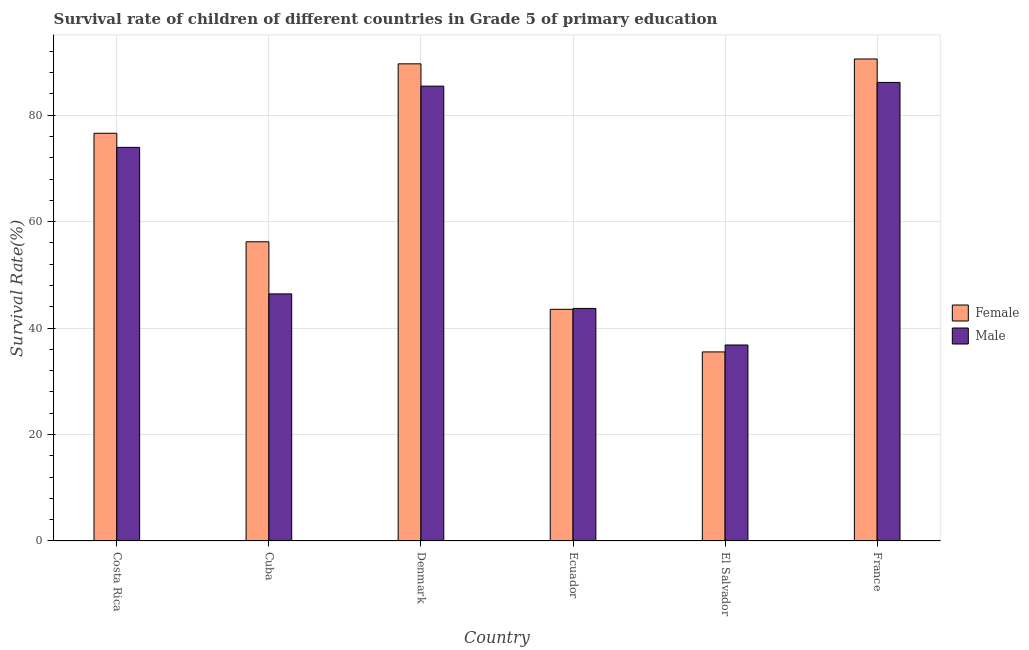How many groups of bars are there?
Your answer should be compact. 6. What is the label of the 6th group of bars from the left?
Provide a short and direct response. France. In how many cases, is the number of bars for a given country not equal to the number of legend labels?
Give a very brief answer. 0. What is the survival rate of female students in primary education in Ecuador?
Your answer should be very brief. 43.53. Across all countries, what is the maximum survival rate of female students in primary education?
Make the answer very short. 90.56. Across all countries, what is the minimum survival rate of female students in primary education?
Offer a terse response. 35.52. In which country was the survival rate of male students in primary education minimum?
Provide a succinct answer. El Salvador. What is the total survival rate of male students in primary education in the graph?
Provide a succinct answer. 372.5. What is the difference between the survival rate of male students in primary education in Costa Rica and that in France?
Offer a very short reply. -12.2. What is the difference between the survival rate of male students in primary education in Ecuador and the survival rate of female students in primary education in Cuba?
Your response must be concise. -12.52. What is the average survival rate of male students in primary education per country?
Keep it short and to the point. 62.08. What is the difference between the survival rate of female students in primary education and survival rate of male students in primary education in Denmark?
Give a very brief answer. 4.19. What is the ratio of the survival rate of female students in primary education in Ecuador to that in France?
Offer a very short reply. 0.48. Is the survival rate of female students in primary education in El Salvador less than that in France?
Ensure brevity in your answer.  Yes. What is the difference between the highest and the second highest survival rate of male students in primary education?
Your answer should be compact. 0.7. What is the difference between the highest and the lowest survival rate of female students in primary education?
Provide a succinct answer. 55.04. In how many countries, is the survival rate of male students in primary education greater than the average survival rate of male students in primary education taken over all countries?
Provide a succinct answer. 3. Are all the bars in the graph horizontal?
Keep it short and to the point. No. How many countries are there in the graph?
Offer a terse response. 6. Are the values on the major ticks of Y-axis written in scientific E-notation?
Keep it short and to the point. No. Does the graph contain any zero values?
Provide a short and direct response. No. Does the graph contain grids?
Provide a short and direct response. Yes. What is the title of the graph?
Provide a succinct answer. Survival rate of children of different countries in Grade 5 of primary education. What is the label or title of the X-axis?
Your answer should be compact. Country. What is the label or title of the Y-axis?
Your response must be concise. Survival Rate(%). What is the Survival Rate(%) of Female in Costa Rica?
Your response must be concise. 76.6. What is the Survival Rate(%) of Male in Costa Rica?
Give a very brief answer. 73.95. What is the Survival Rate(%) of Female in Cuba?
Your answer should be compact. 56.21. What is the Survival Rate(%) of Male in Cuba?
Your answer should be compact. 46.42. What is the Survival Rate(%) in Female in Denmark?
Offer a terse response. 89.64. What is the Survival Rate(%) of Male in Denmark?
Your response must be concise. 85.46. What is the Survival Rate(%) in Female in Ecuador?
Offer a very short reply. 43.53. What is the Survival Rate(%) of Male in Ecuador?
Offer a terse response. 43.69. What is the Survival Rate(%) of Female in El Salvador?
Your response must be concise. 35.52. What is the Survival Rate(%) of Male in El Salvador?
Make the answer very short. 36.82. What is the Survival Rate(%) of Female in France?
Make the answer very short. 90.56. What is the Survival Rate(%) in Male in France?
Your answer should be very brief. 86.16. Across all countries, what is the maximum Survival Rate(%) of Female?
Make the answer very short. 90.56. Across all countries, what is the maximum Survival Rate(%) of Male?
Offer a very short reply. 86.16. Across all countries, what is the minimum Survival Rate(%) in Female?
Your response must be concise. 35.52. Across all countries, what is the minimum Survival Rate(%) in Male?
Make the answer very short. 36.82. What is the total Survival Rate(%) of Female in the graph?
Offer a terse response. 392.06. What is the total Survival Rate(%) in Male in the graph?
Your answer should be very brief. 372.5. What is the difference between the Survival Rate(%) in Female in Costa Rica and that in Cuba?
Your answer should be very brief. 20.39. What is the difference between the Survival Rate(%) of Male in Costa Rica and that in Cuba?
Offer a terse response. 27.53. What is the difference between the Survival Rate(%) in Female in Costa Rica and that in Denmark?
Provide a short and direct response. -13.04. What is the difference between the Survival Rate(%) in Male in Costa Rica and that in Denmark?
Provide a short and direct response. -11.5. What is the difference between the Survival Rate(%) in Female in Costa Rica and that in Ecuador?
Make the answer very short. 33.07. What is the difference between the Survival Rate(%) of Male in Costa Rica and that in Ecuador?
Provide a succinct answer. 30.26. What is the difference between the Survival Rate(%) of Female in Costa Rica and that in El Salvador?
Give a very brief answer. 41.08. What is the difference between the Survival Rate(%) in Male in Costa Rica and that in El Salvador?
Provide a succinct answer. 37.13. What is the difference between the Survival Rate(%) of Female in Costa Rica and that in France?
Keep it short and to the point. -13.96. What is the difference between the Survival Rate(%) in Male in Costa Rica and that in France?
Your answer should be very brief. -12.2. What is the difference between the Survival Rate(%) of Female in Cuba and that in Denmark?
Keep it short and to the point. -33.43. What is the difference between the Survival Rate(%) of Male in Cuba and that in Denmark?
Make the answer very short. -39.03. What is the difference between the Survival Rate(%) of Female in Cuba and that in Ecuador?
Your answer should be very brief. 12.69. What is the difference between the Survival Rate(%) of Male in Cuba and that in Ecuador?
Your answer should be compact. 2.73. What is the difference between the Survival Rate(%) in Female in Cuba and that in El Salvador?
Provide a succinct answer. 20.69. What is the difference between the Survival Rate(%) of Male in Cuba and that in El Salvador?
Your answer should be compact. 9.6. What is the difference between the Survival Rate(%) in Female in Cuba and that in France?
Offer a terse response. -34.34. What is the difference between the Survival Rate(%) in Male in Cuba and that in France?
Make the answer very short. -39.73. What is the difference between the Survival Rate(%) of Female in Denmark and that in Ecuador?
Your answer should be compact. 46.12. What is the difference between the Survival Rate(%) of Male in Denmark and that in Ecuador?
Keep it short and to the point. 41.77. What is the difference between the Survival Rate(%) of Female in Denmark and that in El Salvador?
Offer a terse response. 54.12. What is the difference between the Survival Rate(%) in Male in Denmark and that in El Salvador?
Provide a succinct answer. 48.64. What is the difference between the Survival Rate(%) of Female in Denmark and that in France?
Keep it short and to the point. -0.91. What is the difference between the Survival Rate(%) of Male in Denmark and that in France?
Give a very brief answer. -0.7. What is the difference between the Survival Rate(%) of Female in Ecuador and that in El Salvador?
Keep it short and to the point. 8.01. What is the difference between the Survival Rate(%) in Male in Ecuador and that in El Salvador?
Your response must be concise. 6.87. What is the difference between the Survival Rate(%) of Female in Ecuador and that in France?
Ensure brevity in your answer.  -47.03. What is the difference between the Survival Rate(%) in Male in Ecuador and that in France?
Keep it short and to the point. -42.47. What is the difference between the Survival Rate(%) in Female in El Salvador and that in France?
Your answer should be very brief. -55.04. What is the difference between the Survival Rate(%) of Male in El Salvador and that in France?
Provide a succinct answer. -49.33. What is the difference between the Survival Rate(%) in Female in Costa Rica and the Survival Rate(%) in Male in Cuba?
Provide a succinct answer. 30.18. What is the difference between the Survival Rate(%) of Female in Costa Rica and the Survival Rate(%) of Male in Denmark?
Your response must be concise. -8.86. What is the difference between the Survival Rate(%) in Female in Costa Rica and the Survival Rate(%) in Male in Ecuador?
Keep it short and to the point. 32.91. What is the difference between the Survival Rate(%) of Female in Costa Rica and the Survival Rate(%) of Male in El Salvador?
Make the answer very short. 39.78. What is the difference between the Survival Rate(%) of Female in Costa Rica and the Survival Rate(%) of Male in France?
Your response must be concise. -9.56. What is the difference between the Survival Rate(%) of Female in Cuba and the Survival Rate(%) of Male in Denmark?
Ensure brevity in your answer.  -29.24. What is the difference between the Survival Rate(%) in Female in Cuba and the Survival Rate(%) in Male in Ecuador?
Your answer should be very brief. 12.52. What is the difference between the Survival Rate(%) of Female in Cuba and the Survival Rate(%) of Male in El Salvador?
Your answer should be very brief. 19.39. What is the difference between the Survival Rate(%) in Female in Cuba and the Survival Rate(%) in Male in France?
Your answer should be compact. -29.94. What is the difference between the Survival Rate(%) in Female in Denmark and the Survival Rate(%) in Male in Ecuador?
Your answer should be very brief. 45.95. What is the difference between the Survival Rate(%) of Female in Denmark and the Survival Rate(%) of Male in El Salvador?
Your answer should be compact. 52.82. What is the difference between the Survival Rate(%) of Female in Denmark and the Survival Rate(%) of Male in France?
Your response must be concise. 3.49. What is the difference between the Survival Rate(%) in Female in Ecuador and the Survival Rate(%) in Male in El Salvador?
Your response must be concise. 6.71. What is the difference between the Survival Rate(%) of Female in Ecuador and the Survival Rate(%) of Male in France?
Make the answer very short. -42.63. What is the difference between the Survival Rate(%) of Female in El Salvador and the Survival Rate(%) of Male in France?
Provide a succinct answer. -50.64. What is the average Survival Rate(%) of Female per country?
Offer a terse response. 65.34. What is the average Survival Rate(%) in Male per country?
Your answer should be very brief. 62.08. What is the difference between the Survival Rate(%) of Female and Survival Rate(%) of Male in Costa Rica?
Keep it short and to the point. 2.65. What is the difference between the Survival Rate(%) in Female and Survival Rate(%) in Male in Cuba?
Your response must be concise. 9.79. What is the difference between the Survival Rate(%) of Female and Survival Rate(%) of Male in Denmark?
Your answer should be compact. 4.19. What is the difference between the Survival Rate(%) in Female and Survival Rate(%) in Male in Ecuador?
Your response must be concise. -0.16. What is the difference between the Survival Rate(%) in Female and Survival Rate(%) in Male in El Salvador?
Your answer should be very brief. -1.3. What is the difference between the Survival Rate(%) in Female and Survival Rate(%) in Male in France?
Make the answer very short. 4.4. What is the ratio of the Survival Rate(%) of Female in Costa Rica to that in Cuba?
Provide a short and direct response. 1.36. What is the ratio of the Survival Rate(%) in Male in Costa Rica to that in Cuba?
Provide a short and direct response. 1.59. What is the ratio of the Survival Rate(%) in Female in Costa Rica to that in Denmark?
Offer a very short reply. 0.85. What is the ratio of the Survival Rate(%) in Male in Costa Rica to that in Denmark?
Your answer should be compact. 0.87. What is the ratio of the Survival Rate(%) of Female in Costa Rica to that in Ecuador?
Your answer should be compact. 1.76. What is the ratio of the Survival Rate(%) in Male in Costa Rica to that in Ecuador?
Offer a very short reply. 1.69. What is the ratio of the Survival Rate(%) in Female in Costa Rica to that in El Salvador?
Provide a succinct answer. 2.16. What is the ratio of the Survival Rate(%) in Male in Costa Rica to that in El Salvador?
Keep it short and to the point. 2.01. What is the ratio of the Survival Rate(%) in Female in Costa Rica to that in France?
Provide a short and direct response. 0.85. What is the ratio of the Survival Rate(%) of Male in Costa Rica to that in France?
Give a very brief answer. 0.86. What is the ratio of the Survival Rate(%) in Female in Cuba to that in Denmark?
Provide a succinct answer. 0.63. What is the ratio of the Survival Rate(%) of Male in Cuba to that in Denmark?
Provide a short and direct response. 0.54. What is the ratio of the Survival Rate(%) in Female in Cuba to that in Ecuador?
Your response must be concise. 1.29. What is the ratio of the Survival Rate(%) in Male in Cuba to that in Ecuador?
Offer a very short reply. 1.06. What is the ratio of the Survival Rate(%) of Female in Cuba to that in El Salvador?
Make the answer very short. 1.58. What is the ratio of the Survival Rate(%) of Male in Cuba to that in El Salvador?
Your answer should be very brief. 1.26. What is the ratio of the Survival Rate(%) in Female in Cuba to that in France?
Your answer should be very brief. 0.62. What is the ratio of the Survival Rate(%) of Male in Cuba to that in France?
Provide a succinct answer. 0.54. What is the ratio of the Survival Rate(%) in Female in Denmark to that in Ecuador?
Offer a very short reply. 2.06. What is the ratio of the Survival Rate(%) of Male in Denmark to that in Ecuador?
Your answer should be compact. 1.96. What is the ratio of the Survival Rate(%) of Female in Denmark to that in El Salvador?
Your response must be concise. 2.52. What is the ratio of the Survival Rate(%) in Male in Denmark to that in El Salvador?
Offer a very short reply. 2.32. What is the ratio of the Survival Rate(%) in Female in Ecuador to that in El Salvador?
Make the answer very short. 1.23. What is the ratio of the Survival Rate(%) of Male in Ecuador to that in El Salvador?
Offer a terse response. 1.19. What is the ratio of the Survival Rate(%) in Female in Ecuador to that in France?
Offer a very short reply. 0.48. What is the ratio of the Survival Rate(%) in Male in Ecuador to that in France?
Provide a succinct answer. 0.51. What is the ratio of the Survival Rate(%) of Female in El Salvador to that in France?
Make the answer very short. 0.39. What is the ratio of the Survival Rate(%) in Male in El Salvador to that in France?
Give a very brief answer. 0.43. What is the difference between the highest and the second highest Survival Rate(%) in Female?
Offer a terse response. 0.91. What is the difference between the highest and the second highest Survival Rate(%) in Male?
Your answer should be very brief. 0.7. What is the difference between the highest and the lowest Survival Rate(%) in Female?
Offer a terse response. 55.04. What is the difference between the highest and the lowest Survival Rate(%) of Male?
Ensure brevity in your answer.  49.33. 